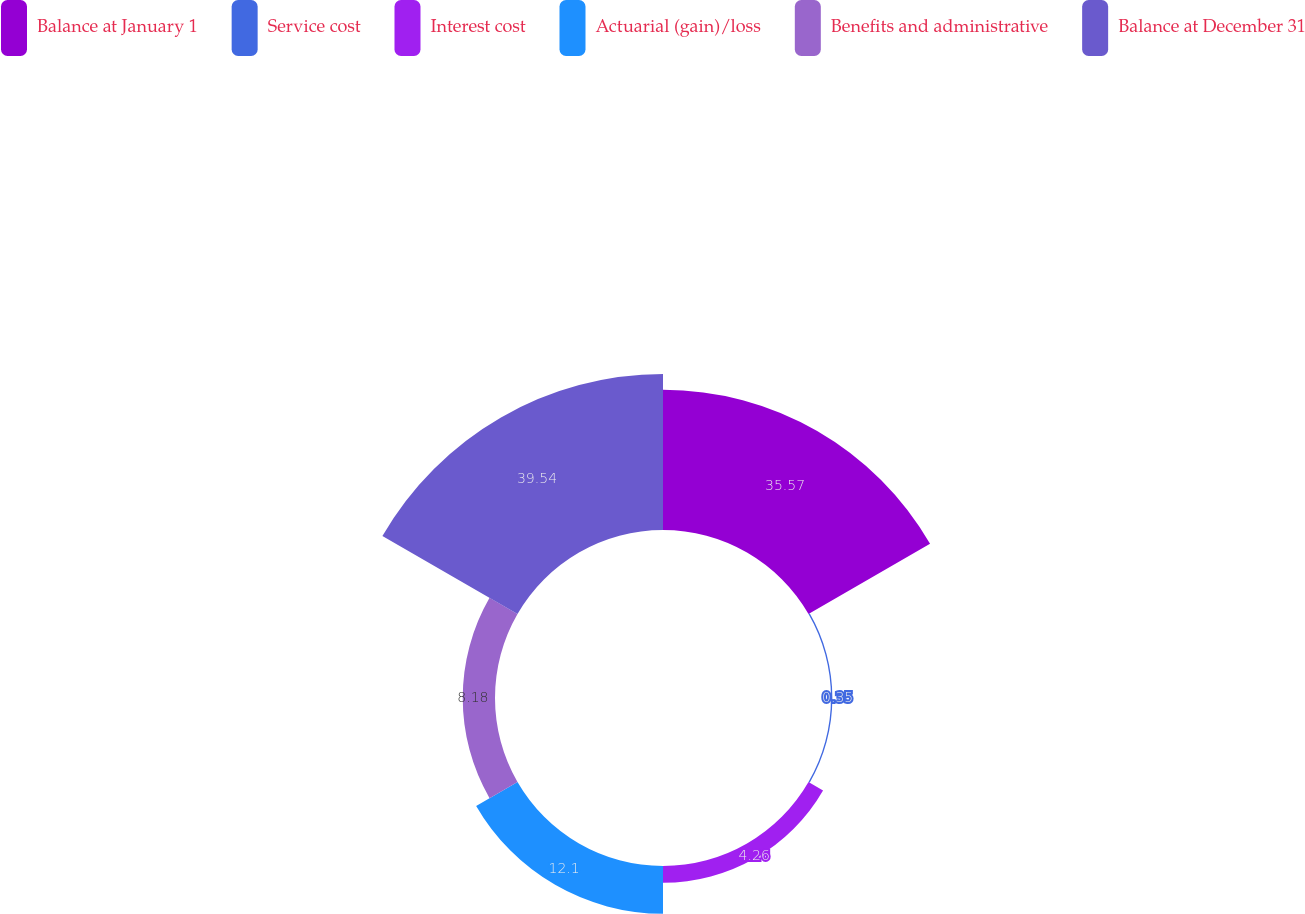<chart> <loc_0><loc_0><loc_500><loc_500><pie_chart><fcel>Balance at January 1<fcel>Service cost<fcel>Interest cost<fcel>Actuarial (gain)/loss<fcel>Benefits and administrative<fcel>Balance at December 31<nl><fcel>35.57%<fcel>0.35%<fcel>4.26%<fcel>12.1%<fcel>8.18%<fcel>39.53%<nl></chart> 